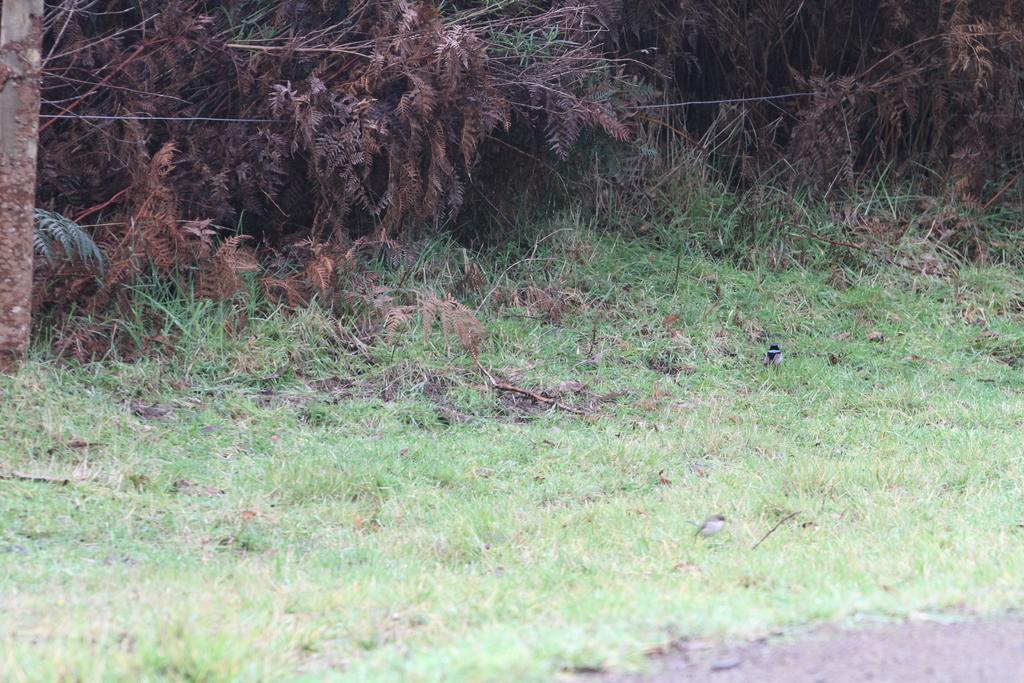What type of vegetation is present in the image? The image contains green grass. What can be seen in the background of the image? There are plants in the background of the image. What is located at the bottom of the image? There is a road at the bottom of the image. What type of tin can be seen being copied for fuel in the image? There is no tin, copying, or fuel present in the image. 